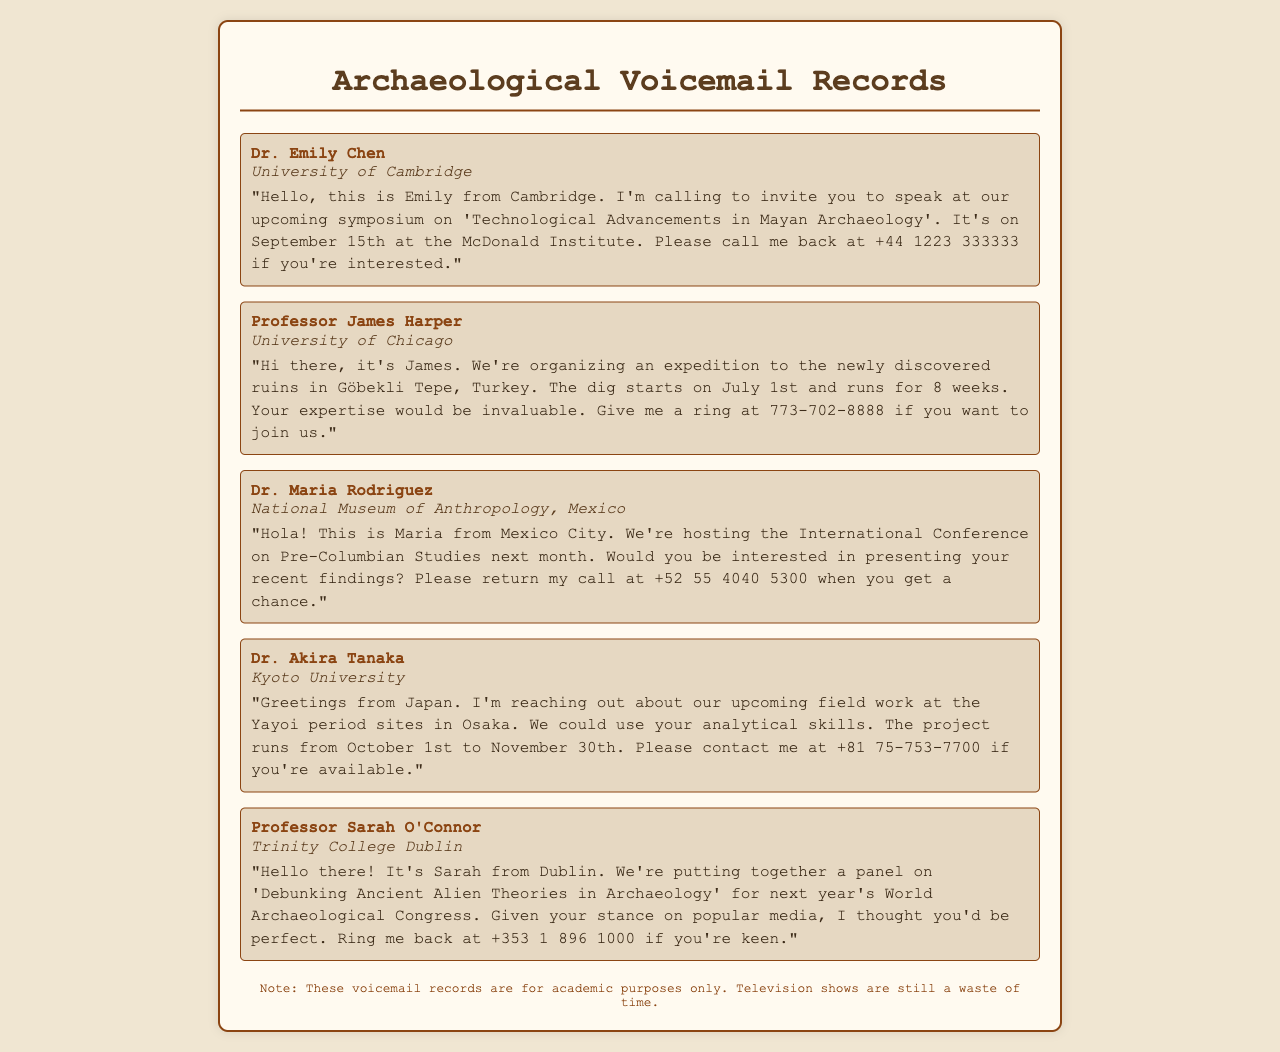What is the date of the Mayan symposium? The voicemail from Dr. Emily Chen states that the symposium on 'Technological Advancements in Mayan Archaeology' is on September 15th.
Answer: September 15th Who is organizing the expedition to Göbekli Tepe? The voicemail from Professor James Harper indicates that the University of Chicago is organizing the expedition.
Answer: University of Chicago What is the duration of the excavation at Göbekli Tepe? Professor James Harper's voicemail mentions that the dig runs for 8 weeks.
Answer: 8 weeks Who is the caller from the National Museum of Anthropology? The voicemail states that Dr. Maria Rodriguez is the caller from the National Museum of Anthropology in Mexico.
Answer: Dr. Maria Rodriguez What type of event is being hosted next month in Mexico City? The voicemail from Dr. Maria Rodriguez describes the event as the International Conference on Pre-Columbian Studies.
Answer: International Conference on Pre-Columbian Studies What is the project duration for the Yayoi period sites in Osaka? Dr. Akira Tanaka's voicemail states that the project runs from October 1st to November 30th.
Answer: October 1st to November 30th Which university is associated with the panel on 'Debunking Ancient Alien Theories'? The voicemail from Professor Sarah O'Connor indicates that Trinity College Dublin is associated with this panel.
Answer: Trinity College Dublin What shared theme do the invitations focus on? Each voicemail invites participation in events related to archaeology, indicating a common theme of archaeological research and scholarly collaboration.
Answer: Archaeology How should one respond to Dr. Emily Chen's voicemail? The voicemail provides Dr. Emily Chen's contact number for call-backs: +44 1223 333333.
Answer: +44 1223 333333 